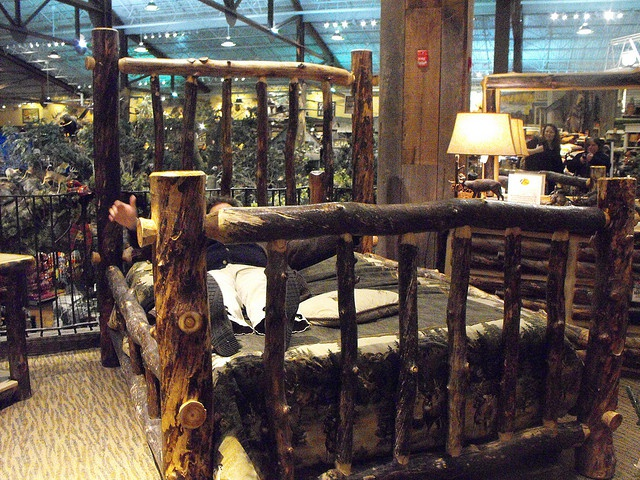Describe the objects in this image and their specific colors. I can see bed in gray, black, and maroon tones, people in gray, black, ivory, and brown tones, people in gray, black, and maroon tones, and people in gray, black, maroon, and brown tones in this image. 